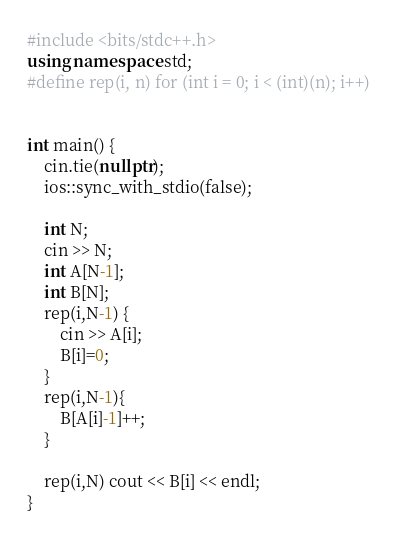<code> <loc_0><loc_0><loc_500><loc_500><_C++_>#include <bits/stdc++.h>
using namespace std;
#define rep(i, n) for (int i = 0; i < (int)(n); i++)


int main() {
    cin.tie(nullptr);
    ios::sync_with_stdio(false);

    int N;
    cin >> N;
    int A[N-1];
    int B[N];
    rep(i,N-1) {
        cin >> A[i];
        B[i]=0;
    }
    rep(i,N-1){
        B[A[i]-1]++;
    }

    rep(i,N) cout << B[i] << endl;
}</code> 